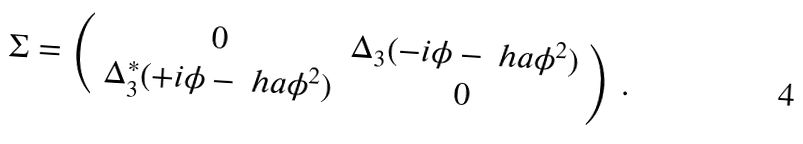<formula> <loc_0><loc_0><loc_500><loc_500>\Sigma = \left ( \begin{array} { c c } 0 & \Delta _ { 3 } ( - i \phi - \ h a \phi ^ { 2 } ) \\ \Delta _ { 3 } ^ { * } ( + i \phi - \ h a \phi ^ { 2 } ) & 0 \end{array} \right ) \, .</formula> 